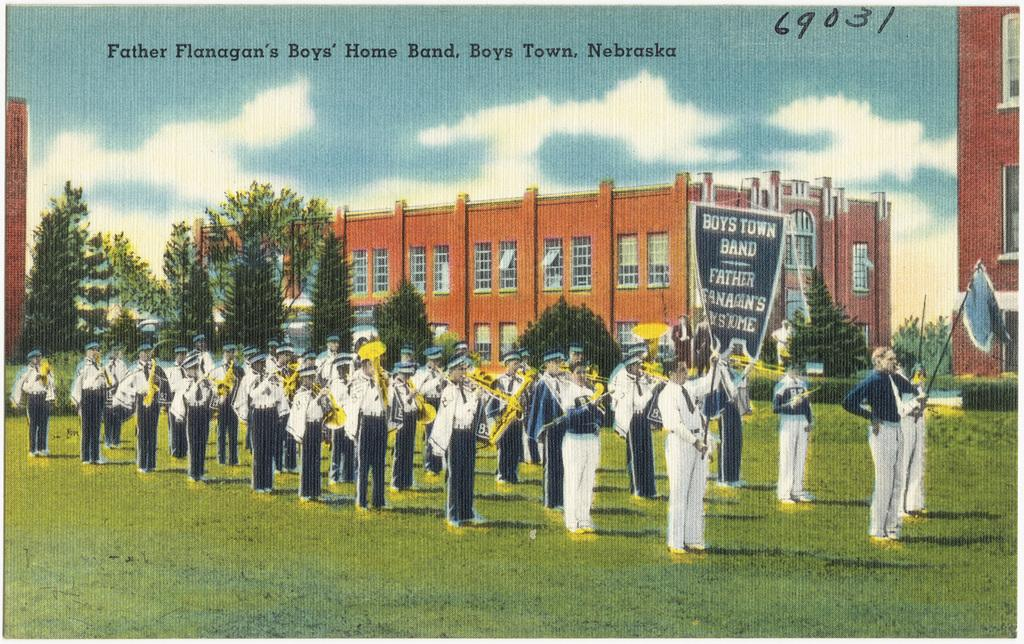<image>
Provide a brief description of the given image. A school marching band from Boys Town, Nebraska. 